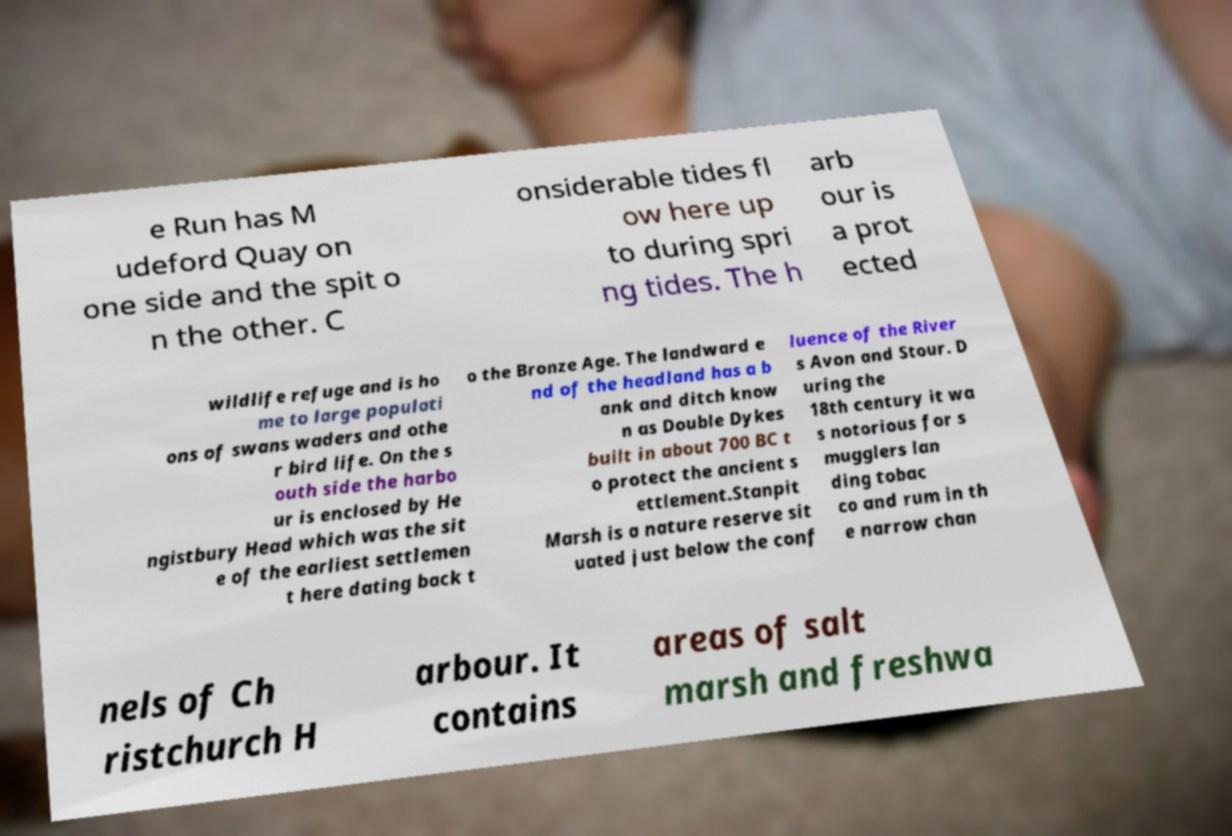Can you accurately transcribe the text from the provided image for me? e Run has M udeford Quay on one side and the spit o n the other. C onsiderable tides fl ow here up to during spri ng tides. The h arb our is a prot ected wildlife refuge and is ho me to large populati ons of swans waders and othe r bird life. On the s outh side the harbo ur is enclosed by He ngistbury Head which was the sit e of the earliest settlemen t here dating back t o the Bronze Age. The landward e nd of the headland has a b ank and ditch know n as Double Dykes built in about 700 BC t o protect the ancient s ettlement.Stanpit Marsh is a nature reserve sit uated just below the conf luence of the River s Avon and Stour. D uring the 18th century it wa s notorious for s mugglers lan ding tobac co and rum in th e narrow chan nels of Ch ristchurch H arbour. It contains areas of salt marsh and freshwa 